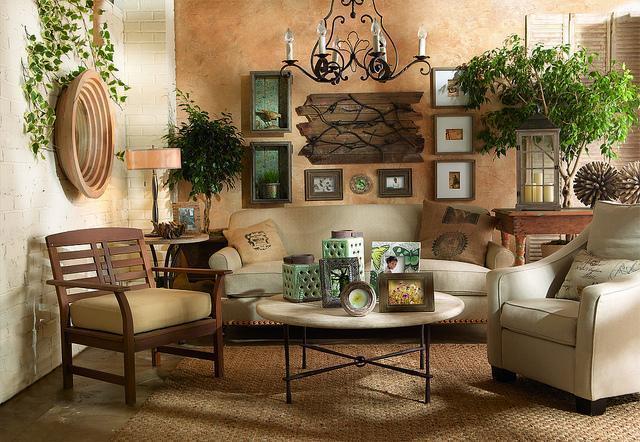How many bowls are in the photo?
Give a very brief answer. 1. How many couches are in the photo?
Give a very brief answer. 2. How many chairs are there?
Give a very brief answer. 2. How many potted plants are in the photo?
Give a very brief answer. 3. 